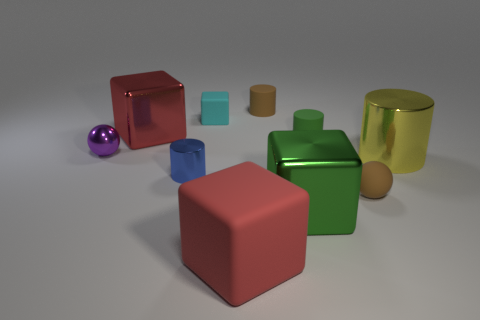There is a big red object that is made of the same material as the small blue cylinder; what shape is it?
Make the answer very short. Cube. The tiny rubber cylinder in front of the red thing that is to the left of the matte cube that is to the right of the cyan thing is what color?
Provide a short and direct response. Green. Are there the same number of metallic cubes that are behind the tiny cyan object and tiny blue shiny objects?
Offer a very short reply. No. Is there any other thing that has the same material as the big green thing?
Ensure brevity in your answer.  Yes. There is a small shiny sphere; is it the same color as the matte cube in front of the blue metallic object?
Keep it short and to the point. No. Are there any small purple spheres that are on the left side of the small matte cylinder in front of the metallic thing that is behind the purple object?
Provide a succinct answer. Yes. Are there fewer tiny metallic objects that are behind the brown rubber cylinder than large matte cylinders?
Ensure brevity in your answer.  No. How many other objects are the same shape as the tiny green thing?
Make the answer very short. 3. What number of objects are tiny objects behind the small cyan rubber block or brown rubber objects behind the green cylinder?
Offer a terse response. 1. There is a metal object that is both behind the tiny blue cylinder and to the right of the large red metallic cube; what size is it?
Provide a succinct answer. Large. 